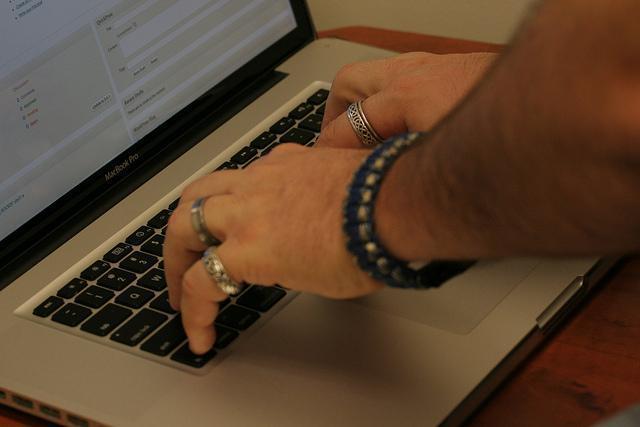How many rings do you see?
Give a very brief answer. 3. How many bracelets do you see?
Give a very brief answer. 1. How many laptops are visible?
Give a very brief answer. 1. 